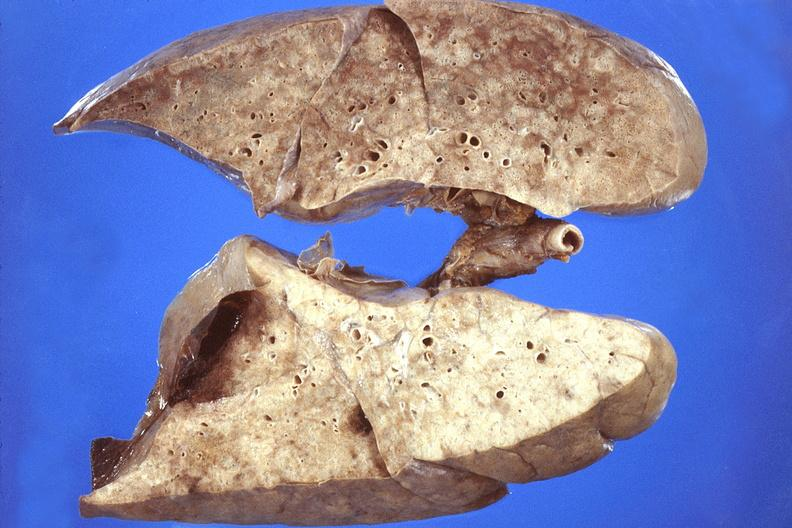what does this image show?
Answer the question using a single word or phrase. Lung 